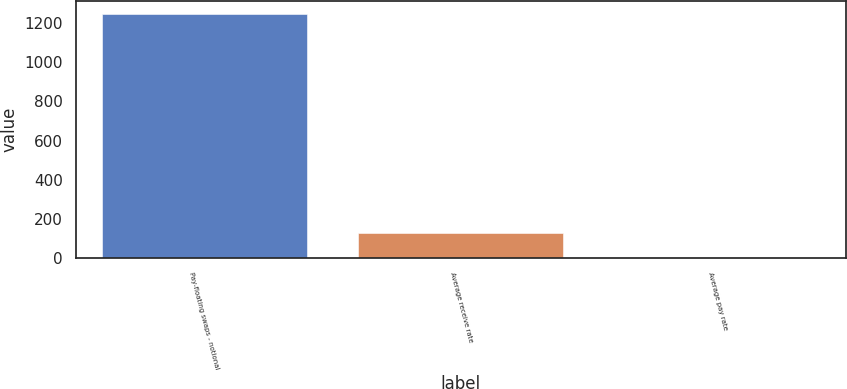Convert chart. <chart><loc_0><loc_0><loc_500><loc_500><bar_chart><fcel>Pay-floating swaps - notional<fcel>Average receive rate<fcel>Average pay rate<nl><fcel>1250<fcel>125.63<fcel>0.7<nl></chart> 